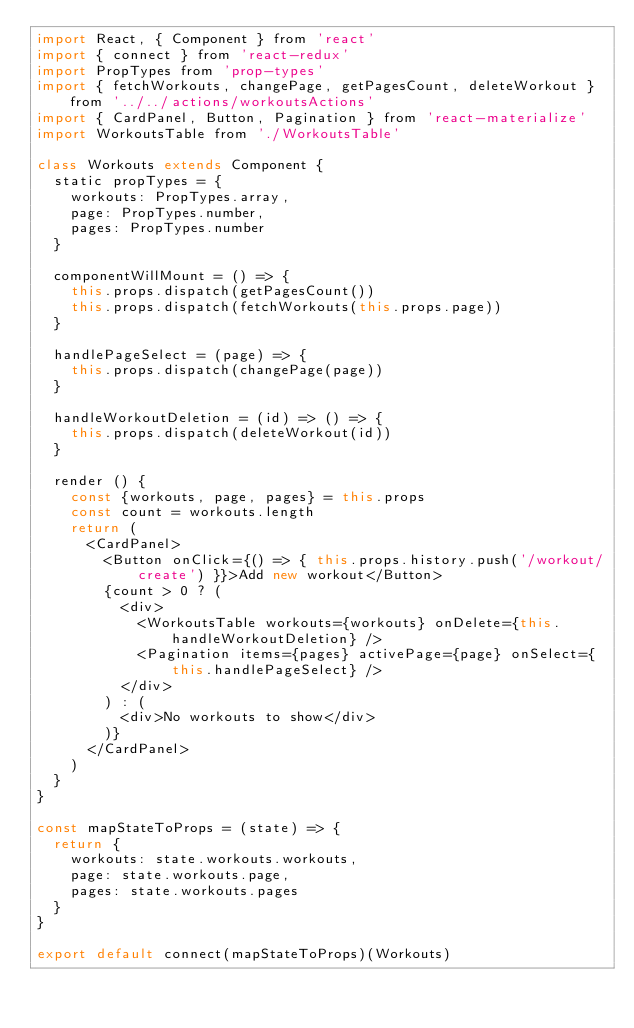Convert code to text. <code><loc_0><loc_0><loc_500><loc_500><_JavaScript_>import React, { Component } from 'react'
import { connect } from 'react-redux'
import PropTypes from 'prop-types'
import { fetchWorkouts, changePage, getPagesCount, deleteWorkout } from '../../actions/workoutsActions'
import { CardPanel, Button, Pagination } from 'react-materialize'
import WorkoutsTable from './WorkoutsTable'

class Workouts extends Component {
  static propTypes = {
    workouts: PropTypes.array,
    page: PropTypes.number,
    pages: PropTypes.number
  }

  componentWillMount = () => {
    this.props.dispatch(getPagesCount())
    this.props.dispatch(fetchWorkouts(this.props.page))
  }

  handlePageSelect = (page) => {
    this.props.dispatch(changePage(page))
  }

  handleWorkoutDeletion = (id) => () => {
    this.props.dispatch(deleteWorkout(id))
  }

  render () {
    const {workouts, page, pages} = this.props
    const count = workouts.length
    return (
      <CardPanel>
        <Button onClick={() => { this.props.history.push('/workout/create') }}>Add new workout</Button>
        {count > 0 ? (
          <div>
            <WorkoutsTable workouts={workouts} onDelete={this.handleWorkoutDeletion} />
            <Pagination items={pages} activePage={page} onSelect={this.handlePageSelect} />
          </div>
        ) : (
          <div>No workouts to show</div>
        )}
      </CardPanel>
    )
  }
}

const mapStateToProps = (state) => {
  return {
    workouts: state.workouts.workouts,
    page: state.workouts.page,
    pages: state.workouts.pages
  }
}

export default connect(mapStateToProps)(Workouts)
</code> 